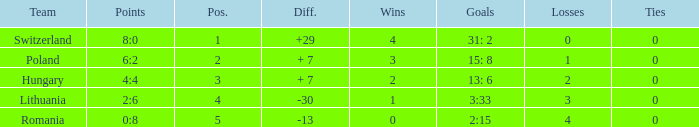What is the most wins when the number of losses was less than 4 and there was more than 0 ties? None. 